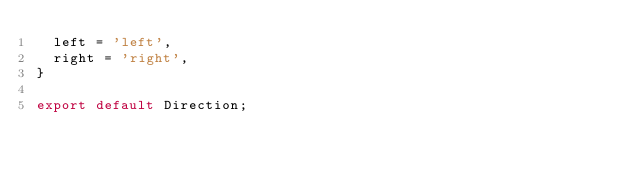<code> <loc_0><loc_0><loc_500><loc_500><_TypeScript_>  left = 'left',
  right = 'right',
}

export default Direction;
</code> 